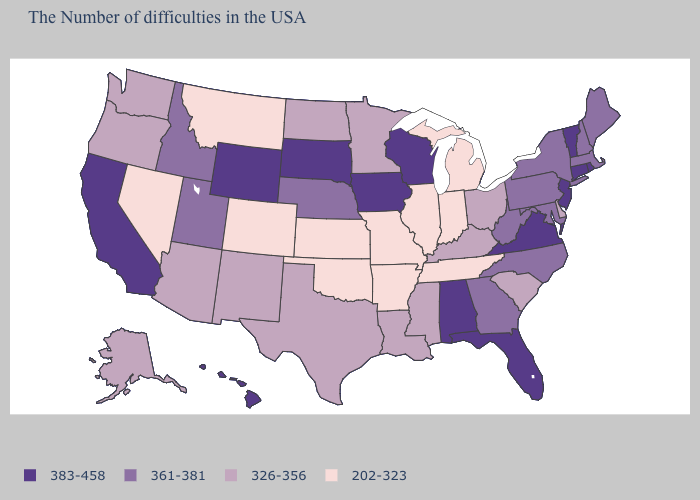Does Idaho have the highest value in the USA?
Write a very short answer. No. What is the value of New York?
Short answer required. 361-381. What is the lowest value in the USA?
Be succinct. 202-323. What is the value of Maine?
Concise answer only. 361-381. Does the first symbol in the legend represent the smallest category?
Give a very brief answer. No. Name the states that have a value in the range 361-381?
Quick response, please. Maine, Massachusetts, New Hampshire, New York, Maryland, Pennsylvania, North Carolina, West Virginia, Georgia, Nebraska, Utah, Idaho. Does Vermont have a higher value than Wyoming?
Write a very short answer. No. Which states have the lowest value in the West?
Answer briefly. Colorado, Montana, Nevada. Does Pennsylvania have the lowest value in the USA?
Quick response, please. No. Among the states that border Michigan , which have the lowest value?
Keep it brief. Indiana. Name the states that have a value in the range 383-458?
Quick response, please. Rhode Island, Vermont, Connecticut, New Jersey, Virginia, Florida, Alabama, Wisconsin, Iowa, South Dakota, Wyoming, California, Hawaii. Name the states that have a value in the range 326-356?
Give a very brief answer. Delaware, South Carolina, Ohio, Kentucky, Mississippi, Louisiana, Minnesota, Texas, North Dakota, New Mexico, Arizona, Washington, Oregon, Alaska. Name the states that have a value in the range 202-323?
Keep it brief. Michigan, Indiana, Tennessee, Illinois, Missouri, Arkansas, Kansas, Oklahoma, Colorado, Montana, Nevada. Which states have the highest value in the USA?
Answer briefly. Rhode Island, Vermont, Connecticut, New Jersey, Virginia, Florida, Alabama, Wisconsin, Iowa, South Dakota, Wyoming, California, Hawaii. 